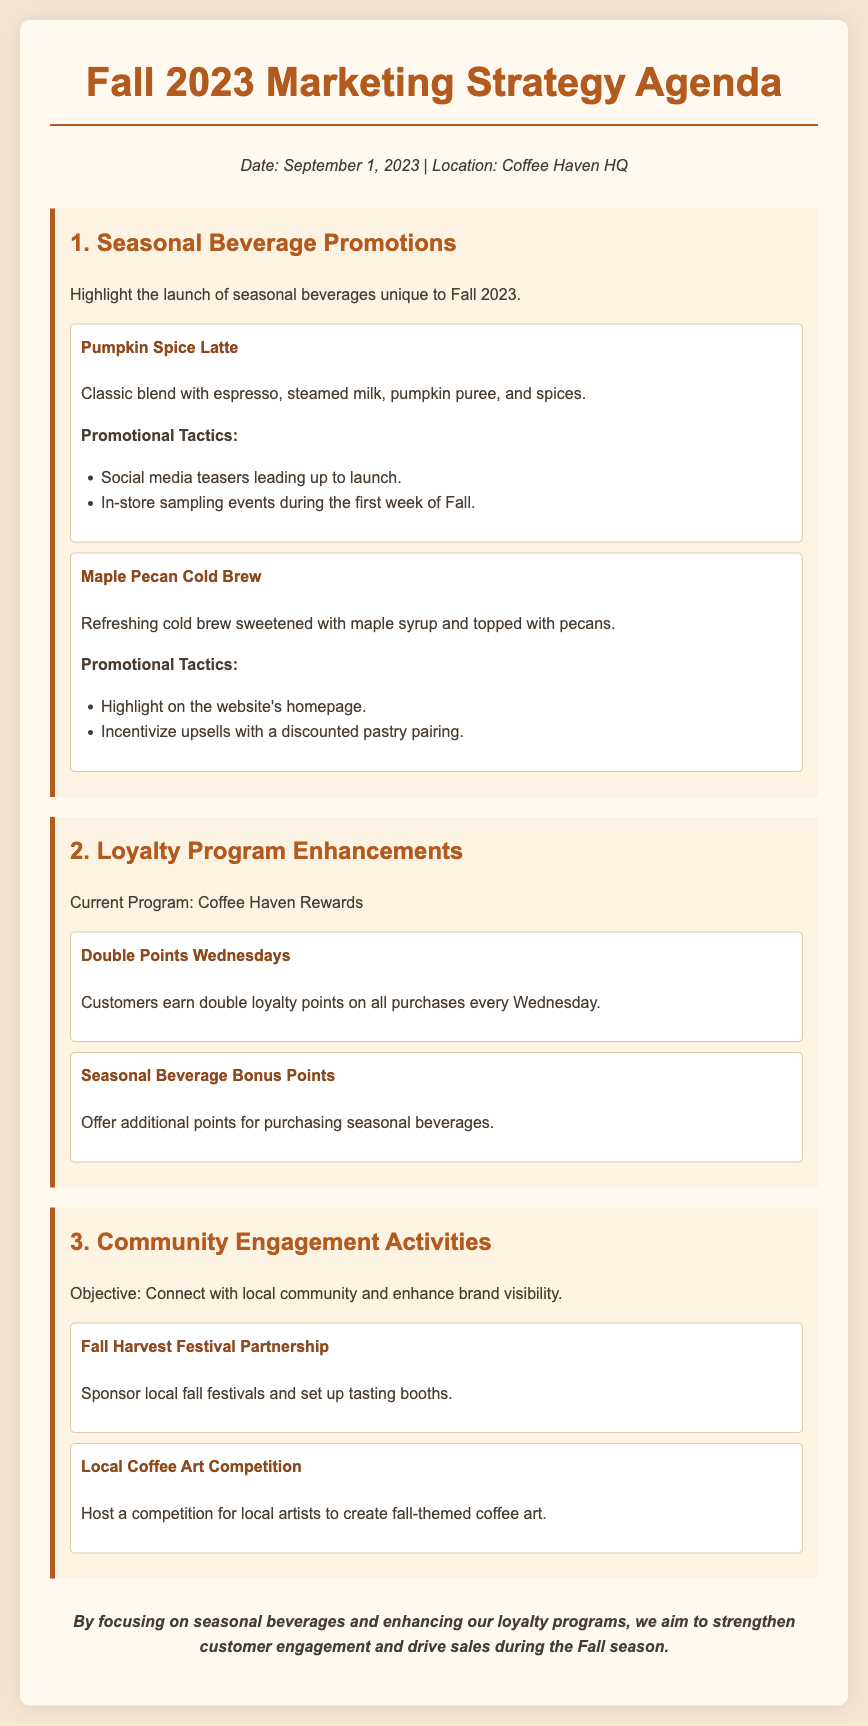What is the title of the document? The title of the document is presented prominently at the top, which identifies the agenda topic for the upcoming season.
Answer: Fall 2023 Marketing Strategy Agenda What is the date of the marketing strategy agenda? The date is mentioned in the meta information section, indicating when this agenda was created or scheduled.
Answer: September 1, 2023 What seasonal beverage is highlighted first in the agenda? The first seasonal beverage detailed in the document, listed under the Seasonal Beverage Promotions section.
Answer: Pumpkin Spice Latte What promotional tactic is suggested for in-store sampling? The document includes this tactic as part of the promotional efforts for the seasonal beverages.
Answer: In-store sampling events during the first week of Fall What does the "Double Points Wednesdays" enhancement refer to? This phrase describes a specific enhancement in the loyalty program section of the agenda aimed at encouraging purchases.
Answer: Customers earn double loyalty points on all purchases every Wednesday How are additional points offered for seasonal beverages? This enhancement indicates a way to reward customers specifically for trying seasonal drinks.
Answer: Offer additional points for purchasing seasonal beverages Which community engagement activity involves a fall festival? The activity mentioned in the document that outlines supporting a local event for visibility and engagement.
Answer: Fall Harvest Festival Partnership What is the primary objective of the community engagement activities? The document states a clear objective related to these activities within its description.
Answer: Connect with local community and enhance brand visibility 